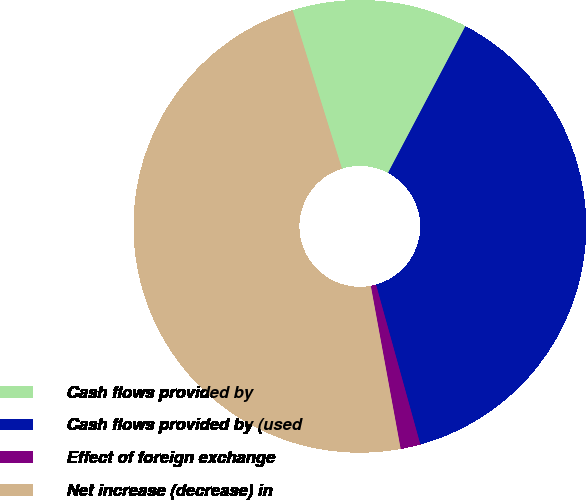Convert chart to OTSL. <chart><loc_0><loc_0><loc_500><loc_500><pie_chart><fcel>Cash flows provided by<fcel>Cash flows provided by (used<fcel>Effect of foreign exchange<fcel>Net increase (decrease) in<nl><fcel>12.53%<fcel>37.97%<fcel>1.42%<fcel>48.08%<nl></chart> 